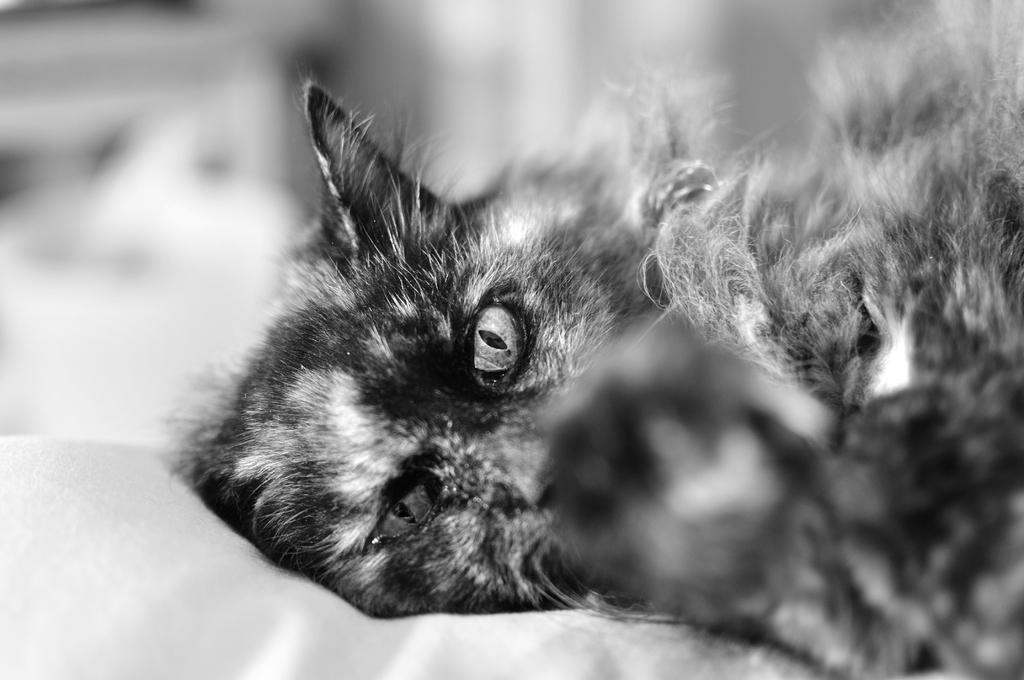What type of animal is in the image? There is a cat in the image. What color scheme is used in the image? The image is black and white in color. How is the background of the image? The background of the image is slightly blurry. How many geese are flying in the image? There are no geese present in the image; it features a cat in a black and white setting. What type of clothing is the cat wearing in the image? Cats do not wear clothing, and there is no clothing visible in the image. 